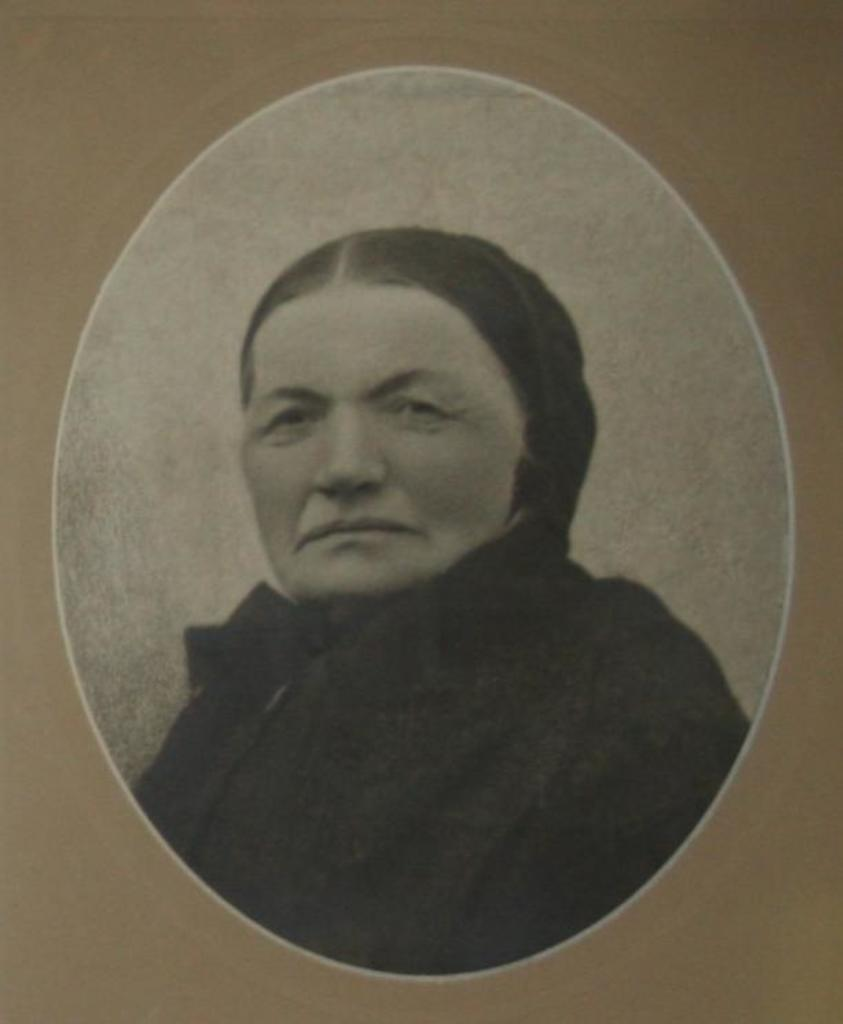What is the main subject of the image? There is a photo of a woman in the image. What can be observed about the background of the image? The background of the image is cream-colored. What type of smell is associated with the photo in the image? There is no smell associated with the photo in the image, as it is a visual representation and not a physical object. 